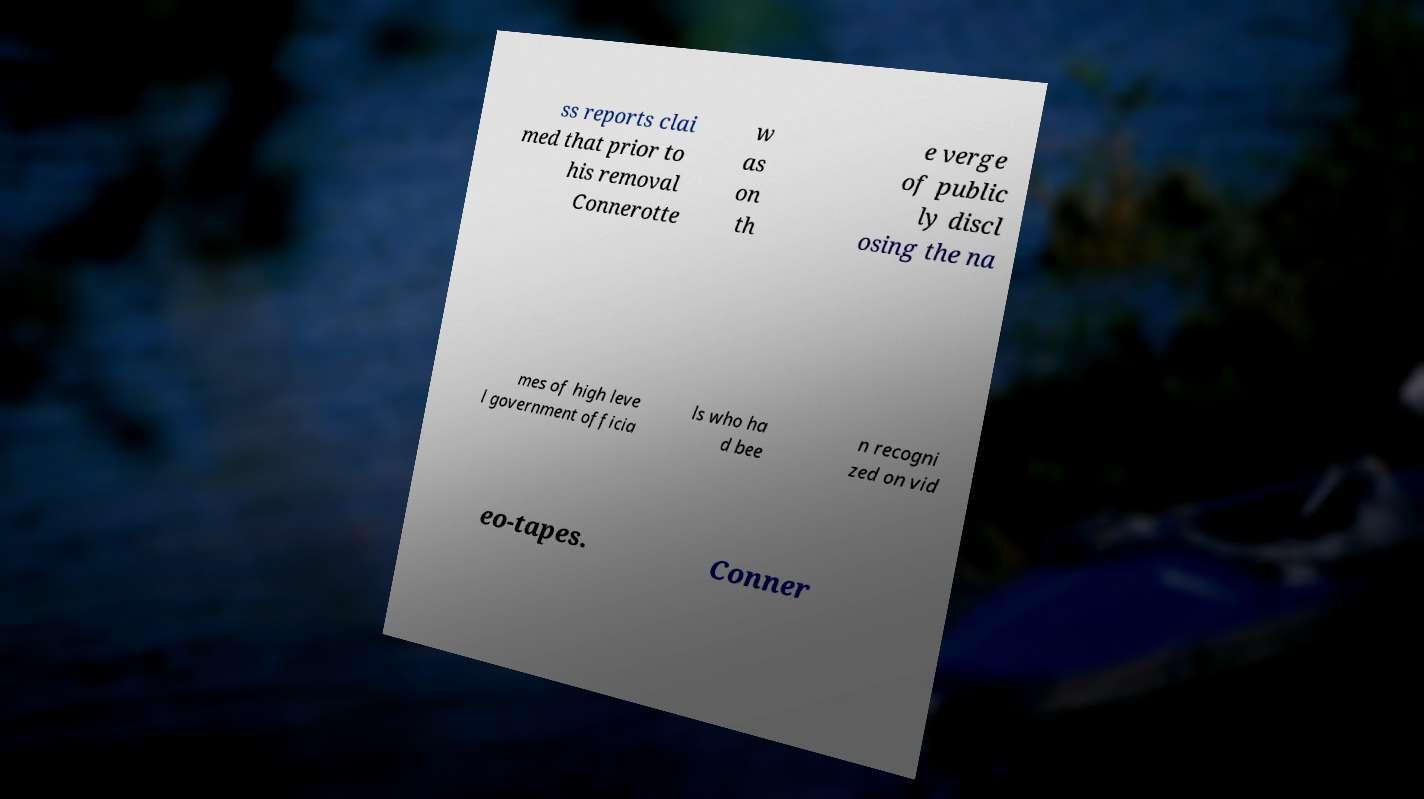I need the written content from this picture converted into text. Can you do that? ss reports clai med that prior to his removal Connerotte w as on th e verge of public ly discl osing the na mes of high leve l government officia ls who ha d bee n recogni zed on vid eo-tapes. Conner 